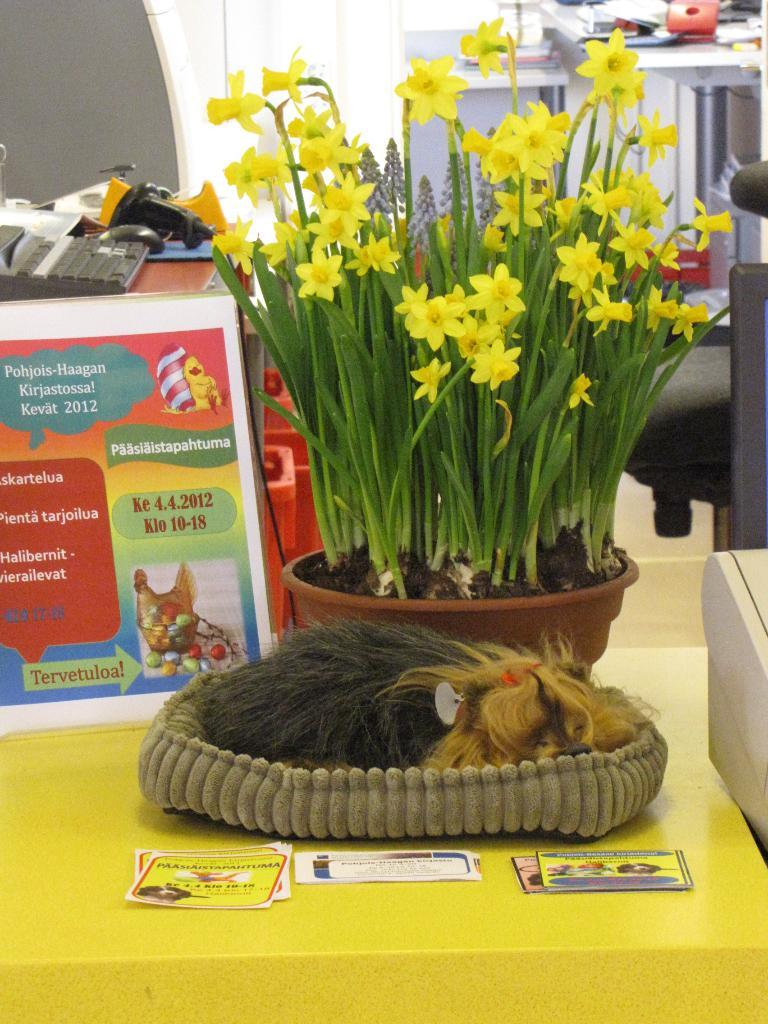What type of plant can be seen in the image? There is a house plant in the image. What electronic device is present in the image? There is a keyboard, a mouse, and a CPU in the image. What type of poster is visible in the image? There is a poster in the image. What type of cards are present in the image? There are cards in the image. What type of toy is visible in the image? There is a toy in the image. What type of lace is used to decorate the house plant in the image? There is no lace used to decorate the house plant in the image. What type of root is visible on the keyboard in the image? There are no roots visible on the keyboard in the image. What type of oil is used to lubricate the toy in the image? There is no oil used to lubricate the toy in the image. 